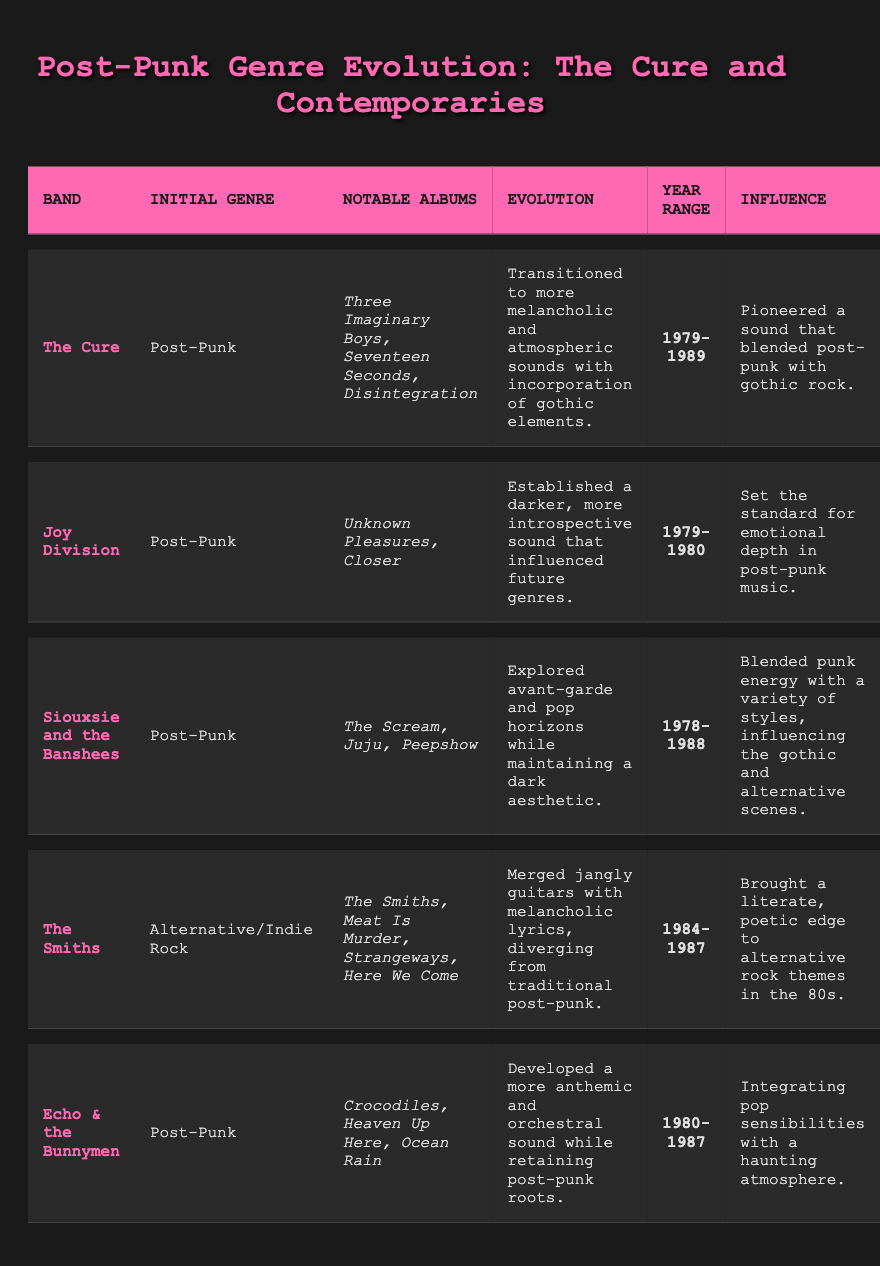What genre did The Cure initially belong to? The table directly states The Cure's initial genre as "Post-Punk." Therefore, we simply refer to the relevant row under "Initial Genre."
Answer: Post-Punk Which band transitioned to a melancholic and atmospheric sound? The table indicates that The Cure transitioned to a more melancholic and atmospheric sound by referencing their evolution description.
Answer: The Cure What are the notable albums of Joy Division? By looking at the row for Joy Division, the notable albums listed are "Unknown Pleasures" and "Closer."
Answer: Unknown Pleasures, Closer Did Siouxsie and the Banshees explore pop horizons? The description of Siouxsie and the Banshees' evolution mentions that they "explored avant-garde and pop horizons," confirming the fact.
Answer: Yes Which band had the year range of 1984-1987? To answer this, we need to check the year range for each band. The table shows The Smiths as having the year range of 1984-1987.
Answer: The Smiths What was the influence of Echo & the Bunnymen? The table states that Echo & the Bunnymen's influence was about "integrating pop sensibilities with a haunting atmosphere."
Answer: Integrating pop sensibilities with a haunting atmosphere How many bands listed initially belonged to the Post-Punk genre? From the table, we see that The Cure, Joy Division, Siouxsie and the Banshees, and Echo & the Bunnymen all belong to the Post-Punk genre. Counting these bands gives us a total of 4.
Answer: 4 Which band had a sound that set the standard for emotional depth in post-punk music? Referring to the influence column for Joy Division, it states they set the standard for emotional depth. Thus, the answer is Joy Division.
Answer: Joy Division What is the average year range of the bands listed? The year ranges need to be converted into numerical values: The Cure (1979-1989) → 1989, Joy Division (1979-1980) → 1980, Siouxsie and the Banshees (1978-1988) → 1988, The Smiths (1984-1987) → 1987, Echo & the Bunnymen (1980-1987) → 1987. Adding these up gives us 1989 + 1980 + 1988 + 1987 + 1987 = 9931. Dividing by 5 results in an average of 1986.2 (rounded to 1986).
Answer: 1986 